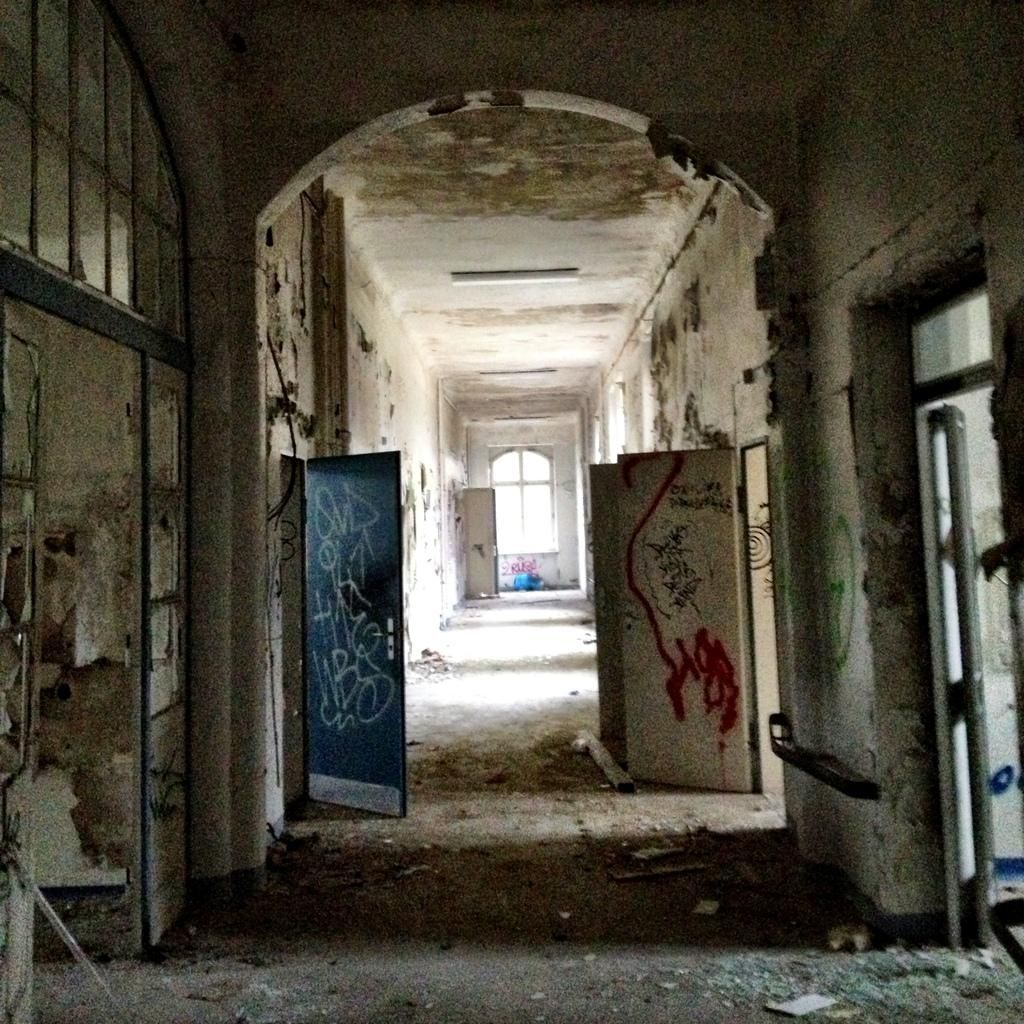What type of structures can be seen in the image? There are doors and walls visible in the image. What is the main feature of the image? The main feature of the image is a path. What can be seen in the background of the image? There is a window in the background of the image. What type of chalk is being used to draw on the base in the image? There is no base or chalk present in the image. What achievements have the achiever accomplished in the image? There is no achiever or accomplishments depicted in the image. 